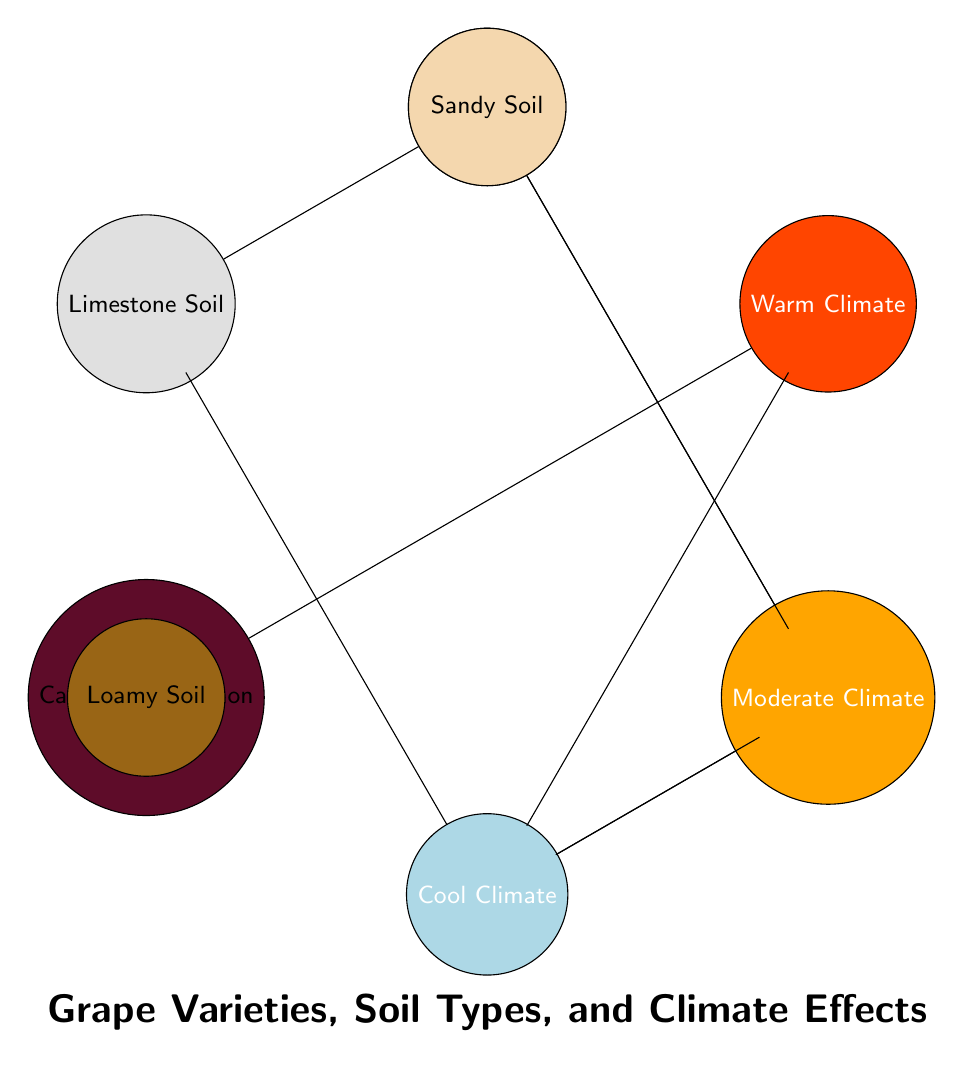What grape variety is associated with clay soil? The diagram shows that Merlot is linked to Clay Soil, making it the grape variety associated with that soil type.
Answer: Merlot How many grape varieties are listed in the diagram? By counting the nodes in the grape variety section of the diagram, we find there are five different grape varieties present: Chardonnay, Pinot Noir, Cabernet Sauvignon, Merlot, and Riesling.
Answer: 5 Which soil type is linked to Cabernet Sauvignon? The data indicates that Cabernet Sauvignon is connected to Loamy Soil, as shown by the link in the diagram.
Answer: Loamy Soil What climate type is associated with Riesling? The diagram indicates that Riesling is linked to Cool Climate, as can be seen in the relationships shown.
Answer: Cool Climate How many links are connected to Chardonnay? Examining the diagram, we can see that there are two links connected to Chardonnay, which are to Limestone Soil and Moderate Climate.
Answer: 2 Which grape variety is associated with warm climate? The diagram shows that Cabernet Sauvignon is connected to the Warm Climate, making it the associated grape variety.
Answer: Cabernet Sauvignon How many soil types are connected to grape varieties? The diagram displays a total of four unique soil types that are each associated with different grape varieties: Clay Soil, Sandy Soil, Limestone Soil, and Loamy Soil.
Answer: 4 What is the primary soil type for Riesling? The visualization illustrates that Riesling is associated with Sandy Soil, making it the primary soil type for this grape variety.
Answer: Sandy Soil Which grape varieties are associated with limestone soil? The diagram shows two grape varieties that are connected to Limestone Soil: Chardonnay and Pinot Noir, which makes them the varieties associated with this soil type.
Answer: Chardonnay, Pinot Noir 